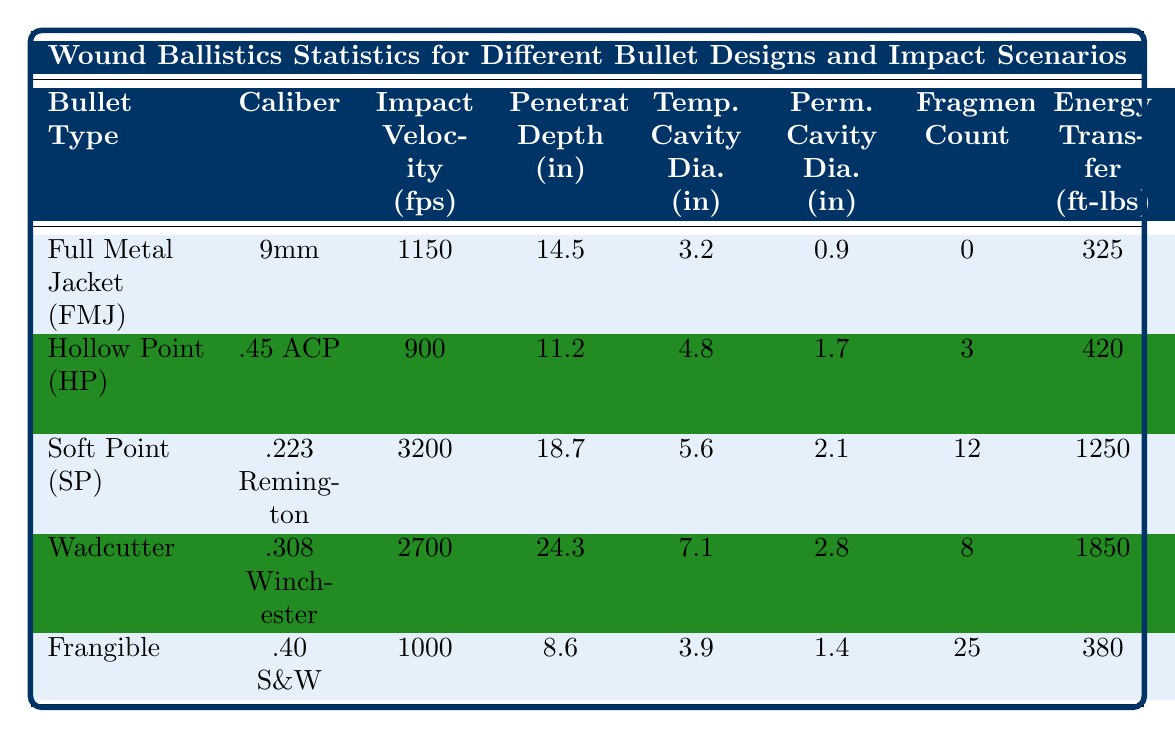What is the impact velocity of the Hollow Point (HP) bullet? The table shows that the impact velocity for the Hollow Point (HP) bullet is listed under the "Impact Velocity (fps)" column, which states 900 fps.
Answer: 900 fps Which bullet type has the greatest penetration depth? By comparing the values in the "Penetration Depth (in)" column, the Wadcutter bullet has the highest value of 24.3 inches.
Answer: Wadcutter Is the energy transfer of the Soft Point (SP) bullet greater than that of the Frangible bullet? The "Energy Transfer (ft-lbs)" for the Soft Point (SP) bullet is 1250 ft-lbs, while for the Frangible bullet it is 380 ft-lbs. Since 1250 is greater than 380, the statement is true.
Answer: Yes What is the average permanent cavity diameter of all bullets? To find the average, sum the values in the "Perm. Cavity Dia. (in)" column: 0.9 + 1.7 + 2.1 + 2.8 + 1.4 = 10.0. Then, divide by the number of bullet types (5): 10.0 / 5 = 2.0 inches.
Answer: 2.0 inches Which bullet produces the highest fragmentation count and what is that count? The "Fragmentation Count" column shows that the Frangible bullet has the highest count, which is 25.
Answer: 25 How does the temporary cavity diameter of the Soft Point (SP) compare to that of the Hollow Point (HP)? The Soft Point (SP) has a temporary cavity diameter of 5.6 inches, while the Hollow Point (HP) has a diameter of 4.8 inches. Therefore, 5.6 inches is greater than 4.8 inches.
Answer: Larger What bullet type has the lowest bullet weight and what is that weight? The "Bullet Weight (gr)" column indicates that the Soft Point (SP) bullet has the lowest weight at 55 grains.
Answer: Soft Point (SP), 55 grains Which bullet type has the highest energy transfer, and what is that amount? The highest value in the "Energy Transfer (ft-lbs)" column is for the Wadcutter, which transfers 1850 ft-lbs.
Answer: Wadcutter, 1850 ft-lbs If you add the penetration depth of the Hollow Point (HP) and Frangible bullets, what is the total? The penetration depth for the Hollow Point (HP) is 11.2 inches and for the Frangible is 8.6 inches. Adding these gives 11.2 + 8.6 = 19.8 inches.
Answer: 19.8 inches Is the impact velocity of the .223 Remington bullet higher than that of the .45 ACP bullet? The impact velocity for .223 Remington is 3200 fps and for .45 ACP is 900 fps, which shows that 3200 is greater than 900, thus the statement is true.
Answer: Yes What is the difference in temporary cavity diameter between the Wadcutter and the Frangible bullets? The temporary cavity diameter for the Wadcutter is 7.1 inches and for the Frangible it is 3.9 inches. The difference is 7.1 - 3.9 = 3.2 inches.
Answer: 3.2 inches 